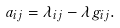Convert formula to latex. <formula><loc_0><loc_0><loc_500><loc_500>a _ { i j } = \lambda _ { i j } - \lambda g _ { i j } .</formula> 